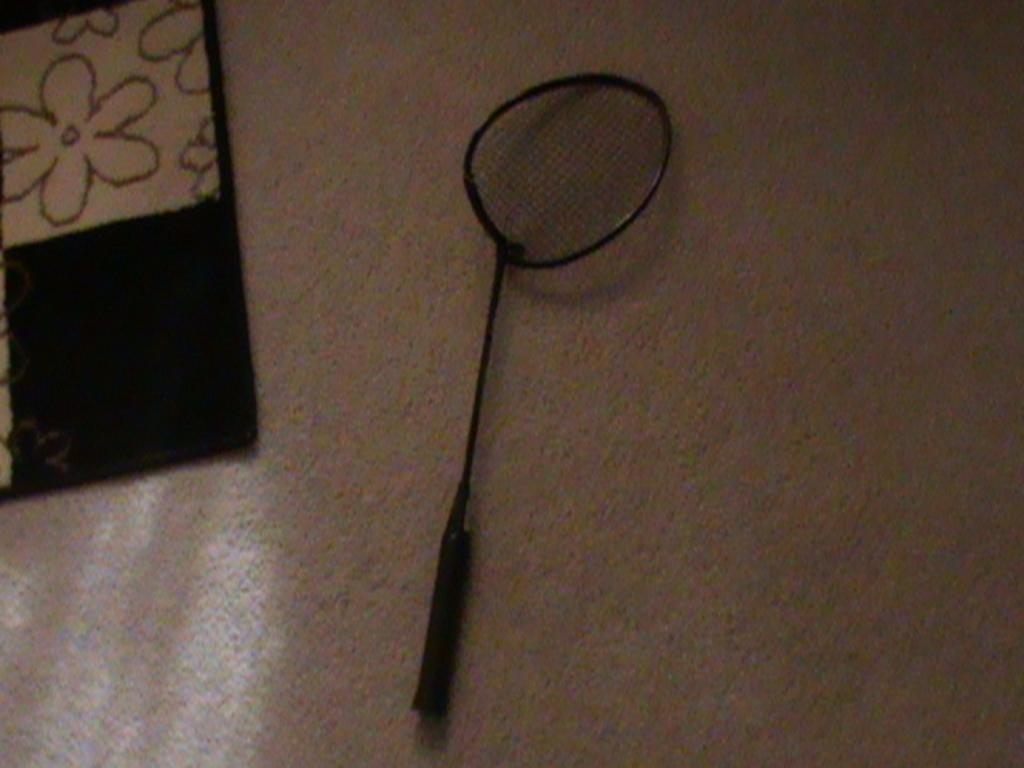What type of sports equipment is visible in the image? There is a badminton racket in the image. Where is the badminton racket located? The badminton racket is hanging on a wall. What type of leather material is used to make the army's bricks in the image? There is no army, bricks, or leather present in the image; it only features a badminton racket hanging on a wall. 